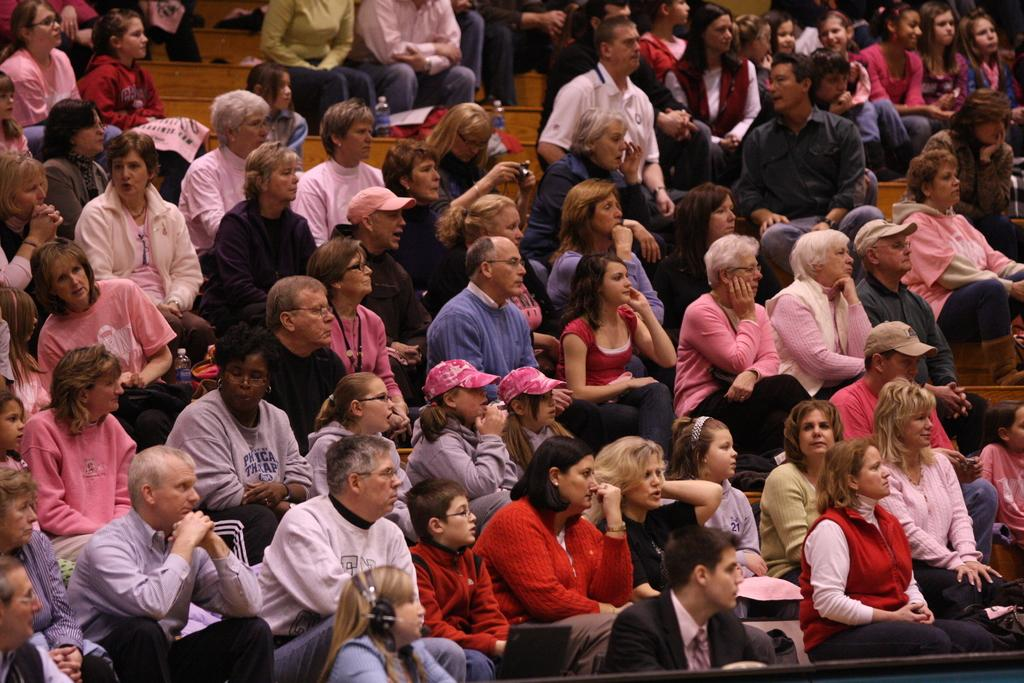How many people are in the image? There are people in the image, but the exact number is not specified. What are some people doing in the image? Some people are sitting on seats in the image. What accessories are some people wearing in the image? Some people are wearing caps in the image. What type of objects with text can be seen in the image? There are posters with text in the image. What type of containers are visible in the image? There are bottles visible in the image. What type of education is being offered in the image? There is no indication of any educational content or activity in the image. What is being served for lunch in the image? There is no mention of food or lunch in the image. 